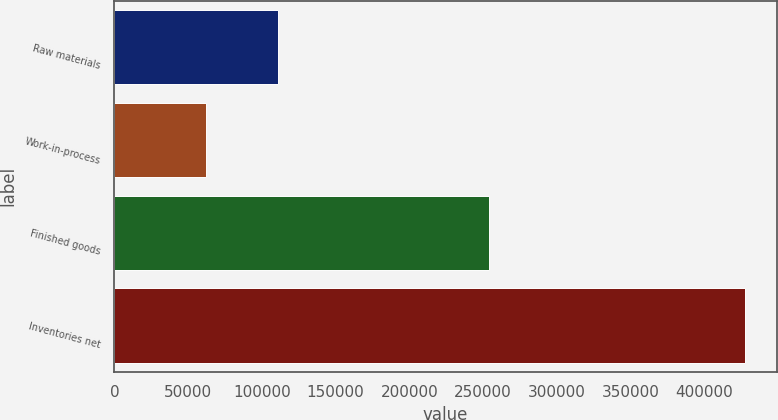<chart> <loc_0><loc_0><loc_500><loc_500><bar_chart><fcel>Raw materials<fcel>Work-in-process<fcel>Finished goods<fcel>Inventories net<nl><fcel>111105<fcel>62334<fcel>254339<fcel>427778<nl></chart> 